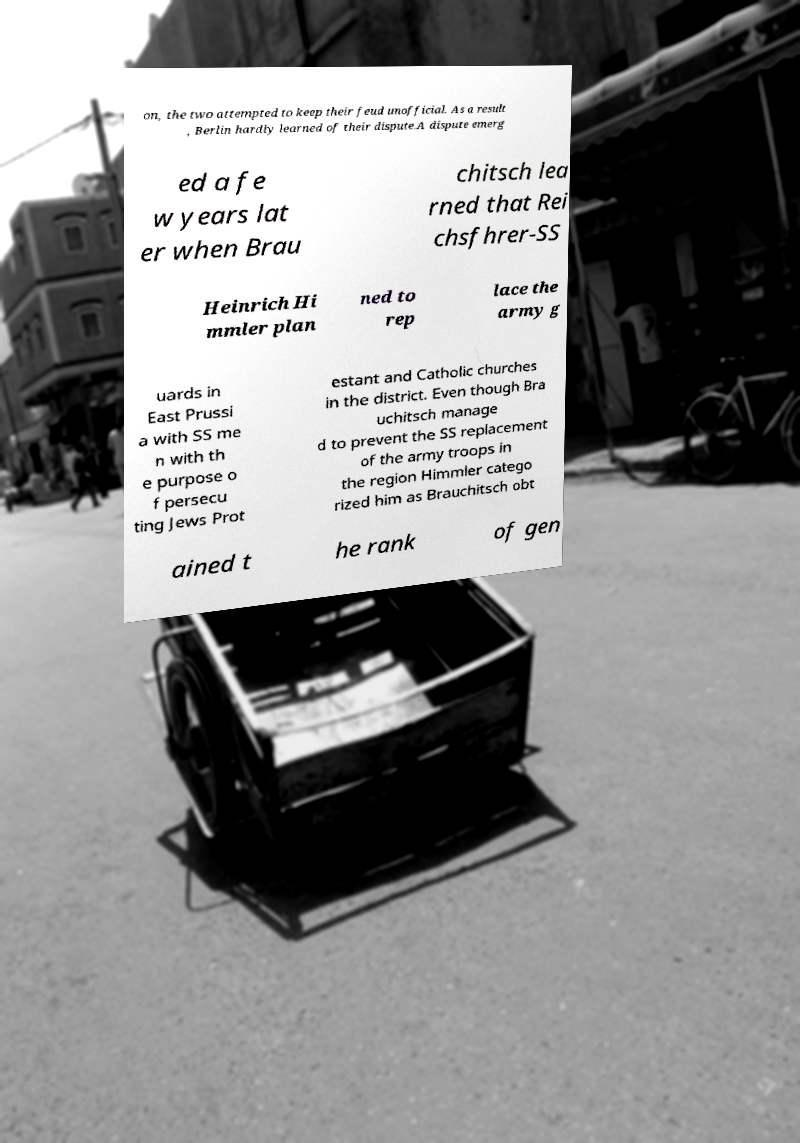Can you read and provide the text displayed in the image?This photo seems to have some interesting text. Can you extract and type it out for me? on, the two attempted to keep their feud unofficial. As a result , Berlin hardly learned of their dispute.A dispute emerg ed a fe w years lat er when Brau chitsch lea rned that Rei chsfhrer-SS Heinrich Hi mmler plan ned to rep lace the army g uards in East Prussi a with SS me n with th e purpose o f persecu ting Jews Prot estant and Catholic churches in the district. Even though Bra uchitsch manage d to prevent the SS replacement of the army troops in the region Himmler catego rized him as Brauchitsch obt ained t he rank of gen 